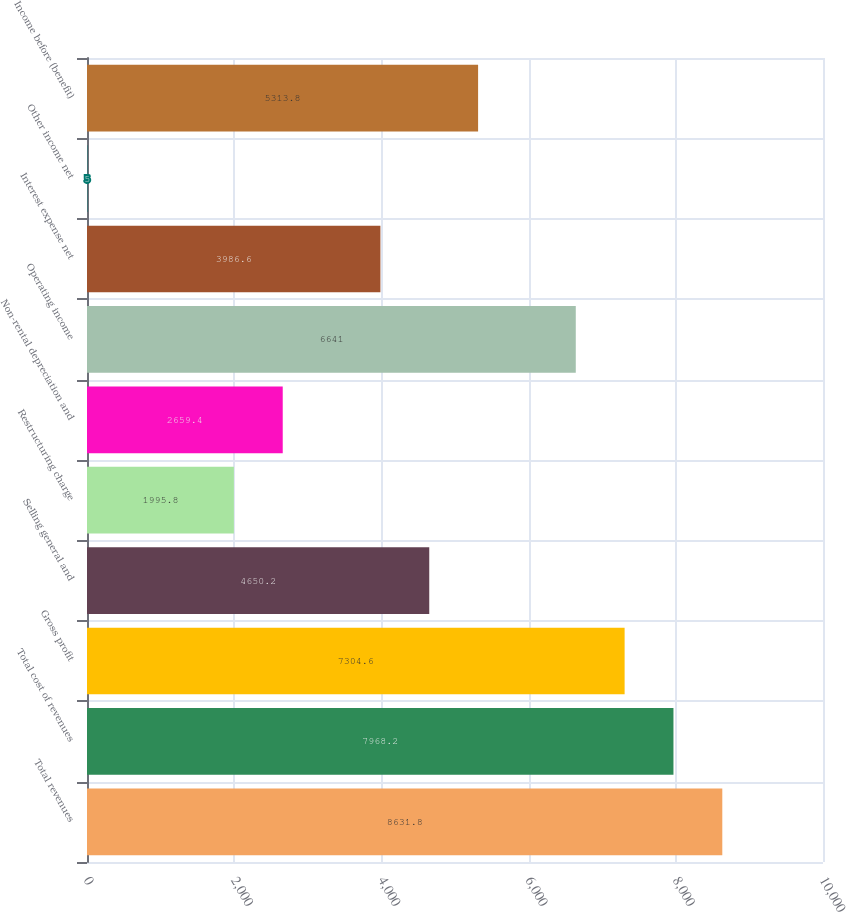Convert chart to OTSL. <chart><loc_0><loc_0><loc_500><loc_500><bar_chart><fcel>Total revenues<fcel>Total cost of revenues<fcel>Gross profit<fcel>Selling general and<fcel>Restructuring charge<fcel>Non-rental depreciation and<fcel>Operating income<fcel>Interest expense net<fcel>Other income net<fcel>Income before (benefit)<nl><fcel>8631.8<fcel>7968.2<fcel>7304.6<fcel>4650.2<fcel>1995.8<fcel>2659.4<fcel>6641<fcel>3986.6<fcel>5<fcel>5313.8<nl></chart> 